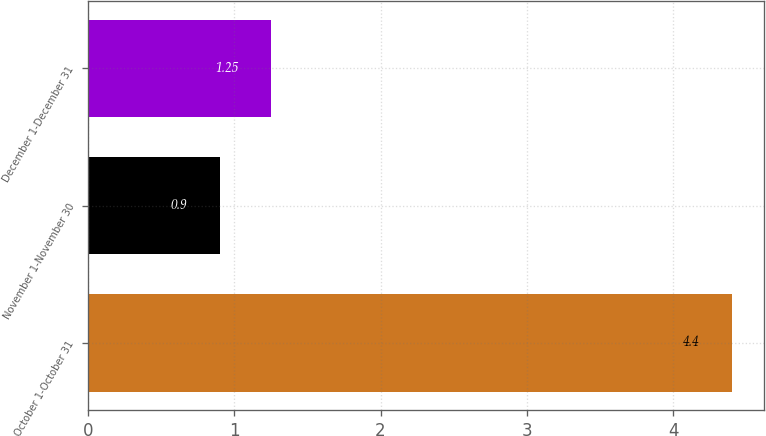Convert chart to OTSL. <chart><loc_0><loc_0><loc_500><loc_500><bar_chart><fcel>October 1-October 31<fcel>November 1-November 30<fcel>December 1-December 31<nl><fcel>4.4<fcel>0.9<fcel>1.25<nl></chart> 